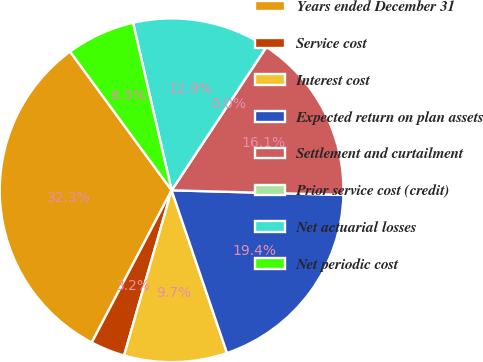Convert chart. <chart><loc_0><loc_0><loc_500><loc_500><pie_chart><fcel>Years ended December 31<fcel>Service cost<fcel>Interest cost<fcel>Expected return on plan assets<fcel>Settlement and curtailment<fcel>Prior service cost (credit)<fcel>Net actuarial losses<fcel>Net periodic cost<nl><fcel>32.26%<fcel>3.23%<fcel>9.68%<fcel>19.35%<fcel>16.13%<fcel>0.0%<fcel>12.9%<fcel>6.45%<nl></chart> 